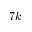Convert formula to latex. <formula><loc_0><loc_0><loc_500><loc_500>7 k</formula> 